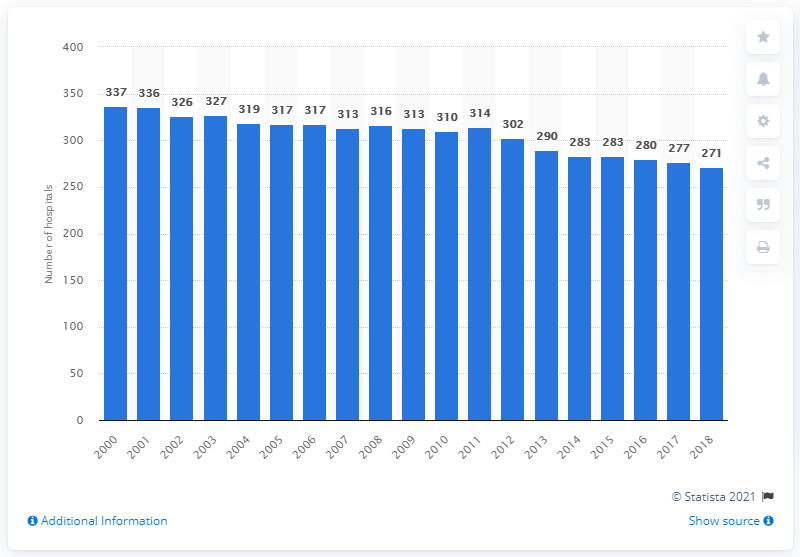Identify some key points in this picture. In 2018, there were 271 hospitals in Greece. 